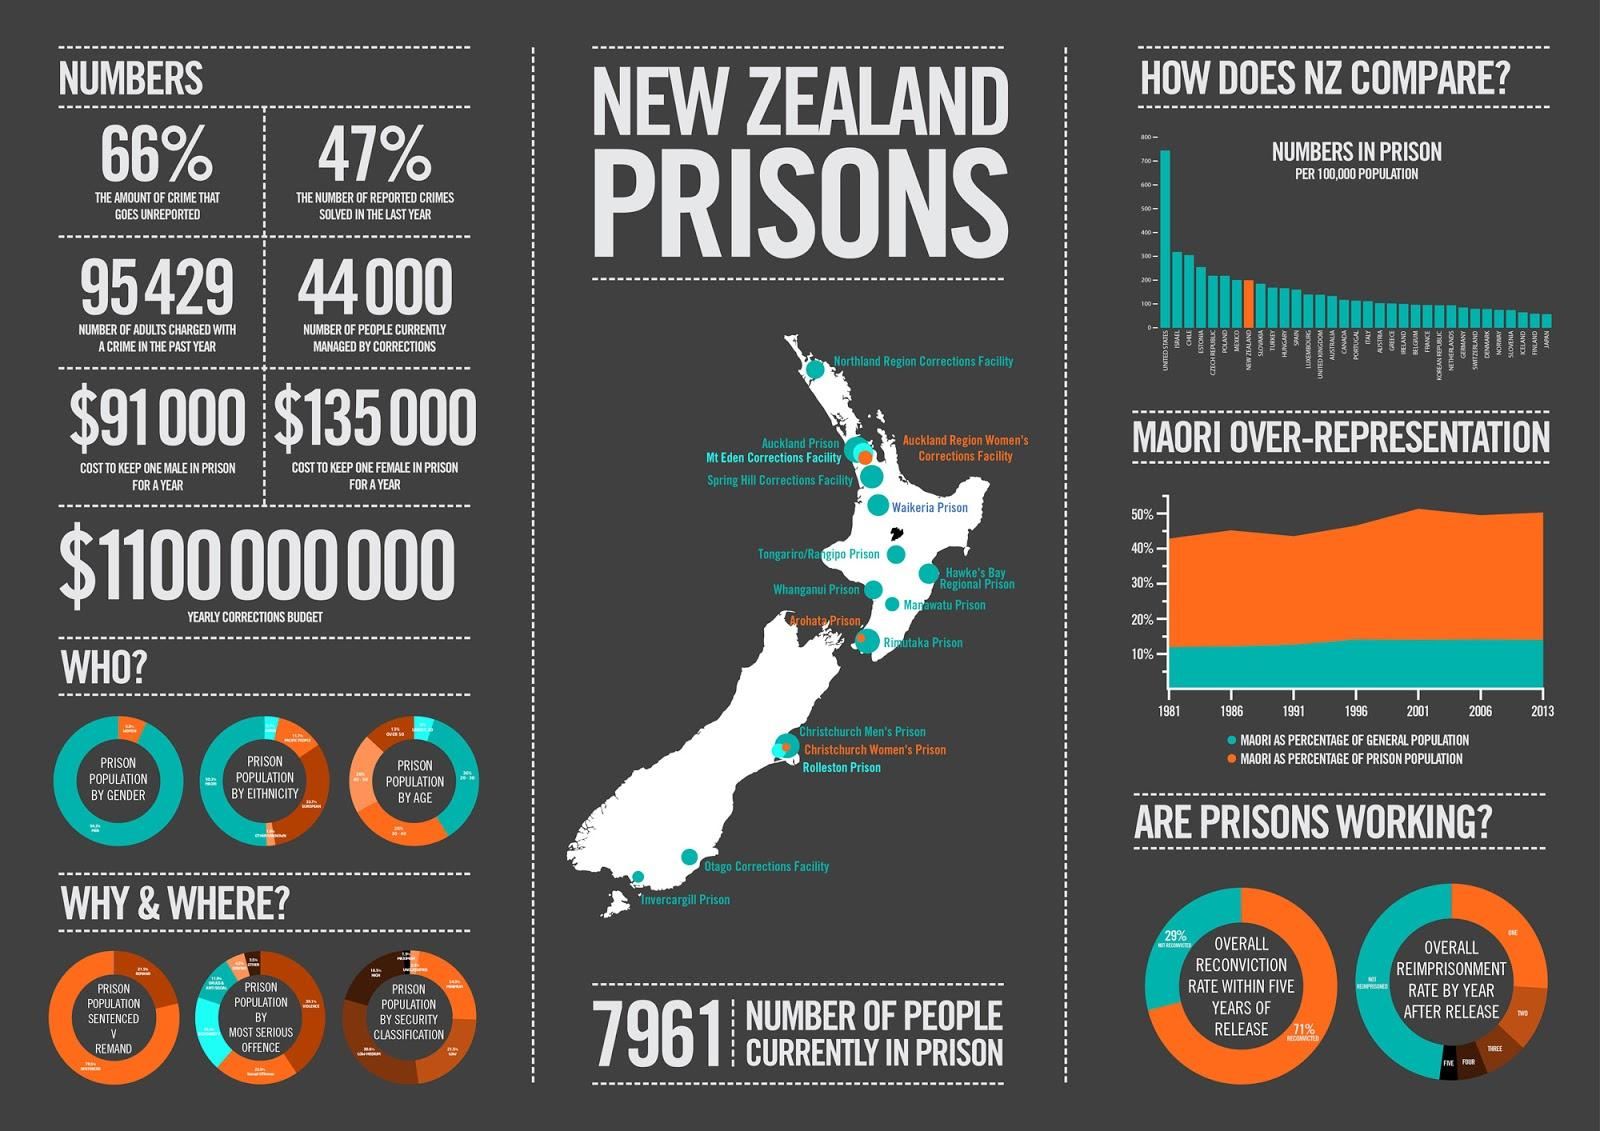Give some essential details in this illustration. According to the latest statistics, New Zealand currently ranks 8th in the world in terms of the number of people in prison. There are three women's prisons in New Zealand. According to the information provided, it is estimated that the additional cost incurred by the New Zealand government in providing for a female prisoner is approximately $44,000. 